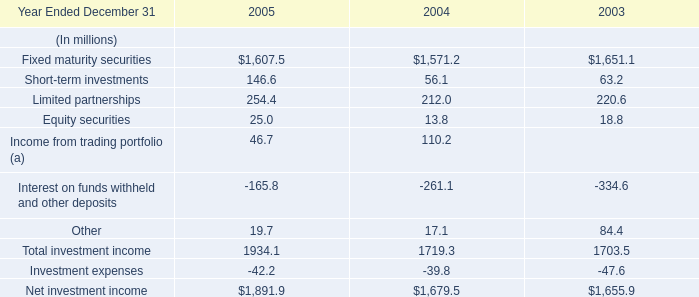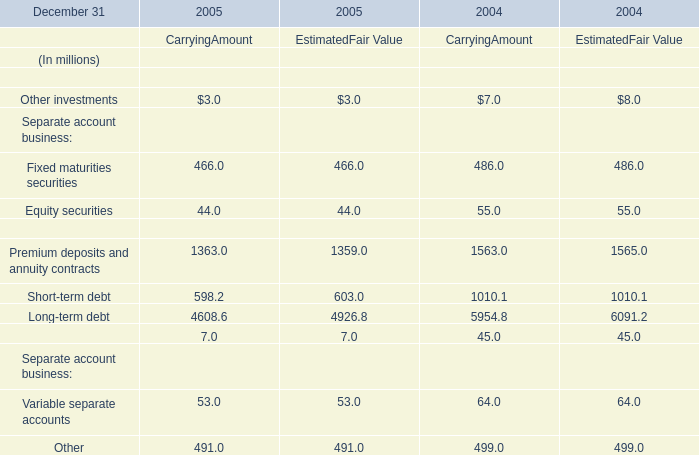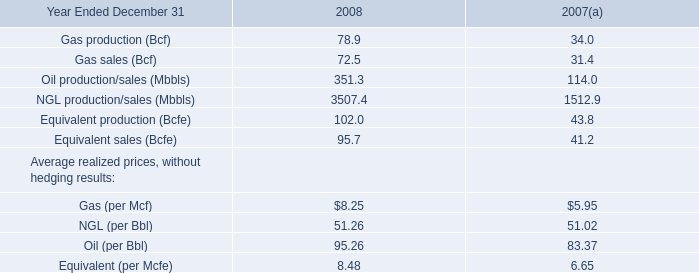What's the sum of the Interest on funds withheld and other deposits in the years where Equity securities for Financial assets for CarryingAmount is greater than 0? (in million) 
Computations: (-165.8 - 261.1)
Answer: -426.9. 